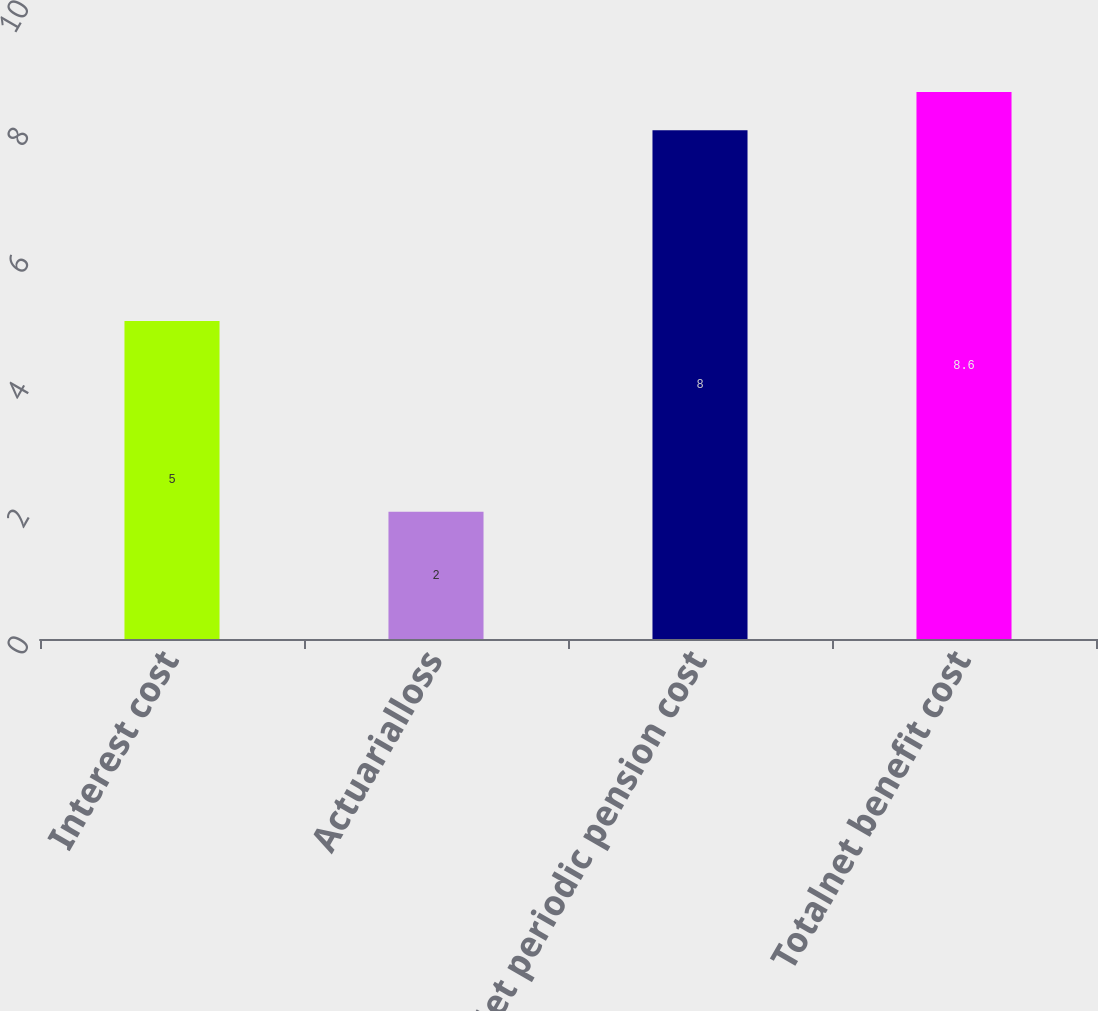Convert chart. <chart><loc_0><loc_0><loc_500><loc_500><bar_chart><fcel>Interest cost<fcel>Actuarialloss<fcel>Net periodic pension cost<fcel>Totalnet benefit cost<nl><fcel>5<fcel>2<fcel>8<fcel>8.6<nl></chart> 